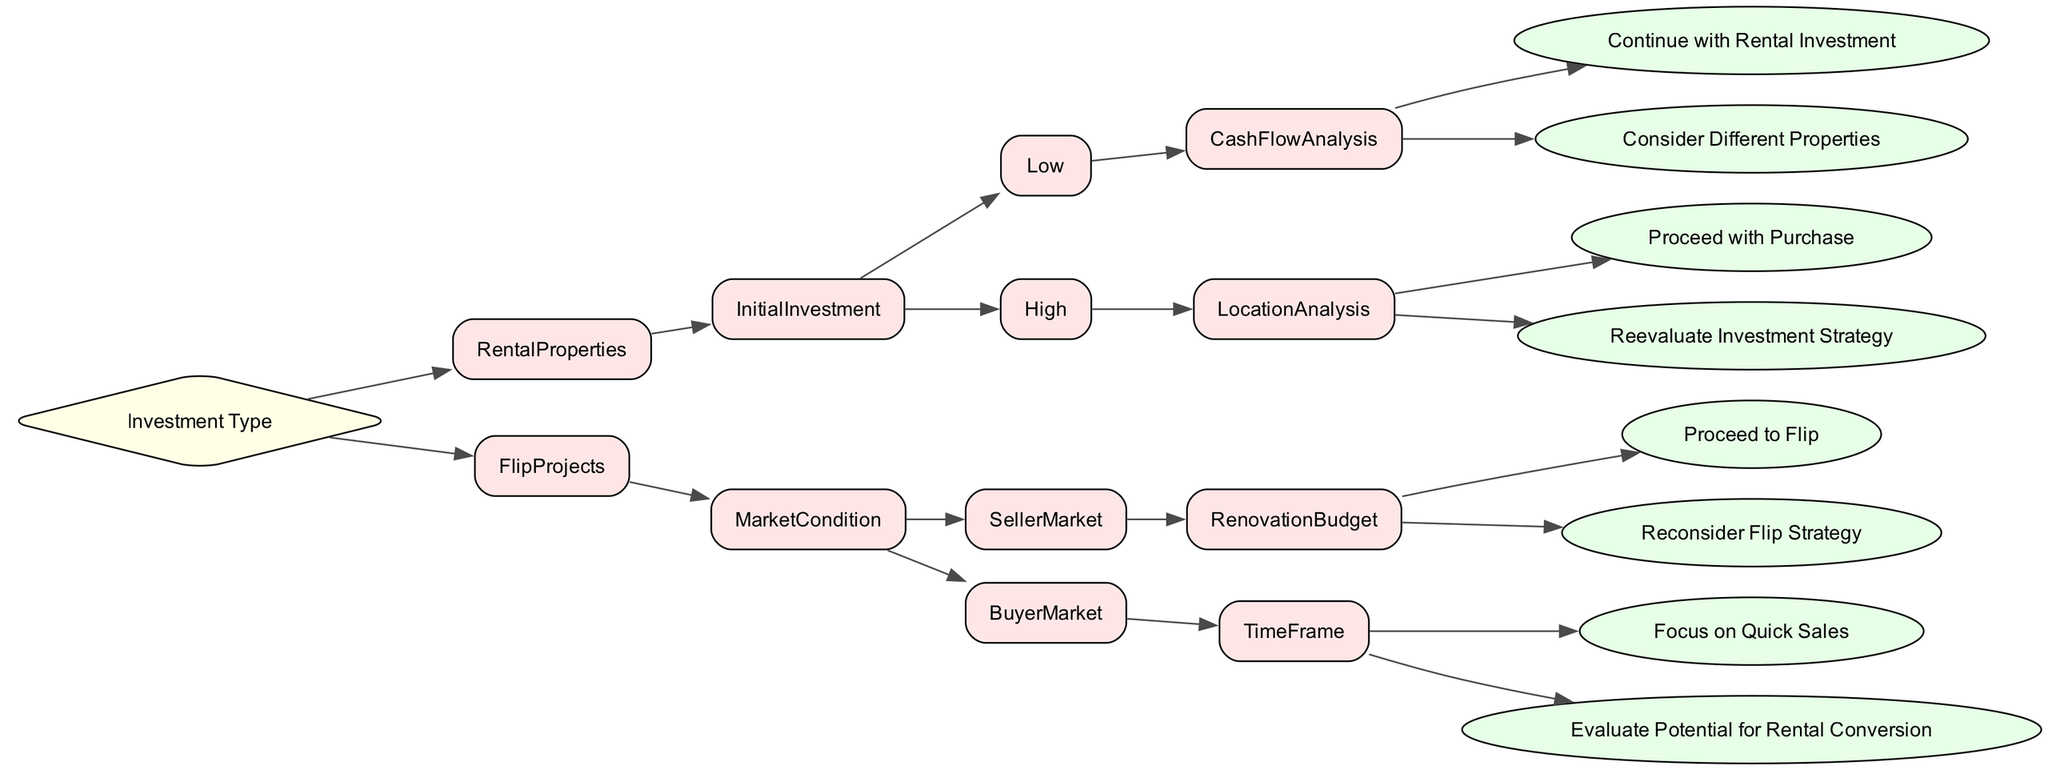What is the first decision point in the diagram? The diagram starts with the 'Investment Type' as the first decision point. It categorizes the investment types into two main branches: Rental Properties and Flip Projects.
Answer: Investment Type How many branches are there under 'Rental Properties'? There are two branches under 'Rental Properties': 'Initial Investment' and 'Cash Flow Analysis'. Hence, it contains two key decision points.
Answer: 2 What should you do if the location analysis shows a low demand area? If the location analysis shows a low demand area, the advice is to reevaluate the investment strategy instead of proceeding with a purchase.
Answer: Reevaluate Investment Strategy In what market condition should you proceed with a flip project? You should proceed with a flip project if you are in a seller's market and your renovation budget is under budget.
Answer: Proceed to Flip What happens if the cash flow analysis is negative for low initial investments? If the cash flow analysis is negative for low initial investments, the recommendation is to consider different properties rather than continuing with the current rental investment.
Answer: Consider Different Properties What is the outcome if the timeframe is short in a buyer's market? If the timeframe is short in a buyer's market, the focus should be on quick sales, meaning you should aim to sell the property as fast as possible.
Answer: Focus on Quick Sales What gets prioritized in a high demand area for rental properties? In a high demand area for rental properties, the next step is to proceed with the purchase since the demand increases the potential for a profitable investment.
Answer: Proceed with Purchase What do you do if your renovation budget is over budget in a seller's market? If your renovation budget is over budget in a seller's market, you need to reconsider your flip strategy to evaluate if it's worth pursuing.
Answer: Reconsider Flip Strategy 